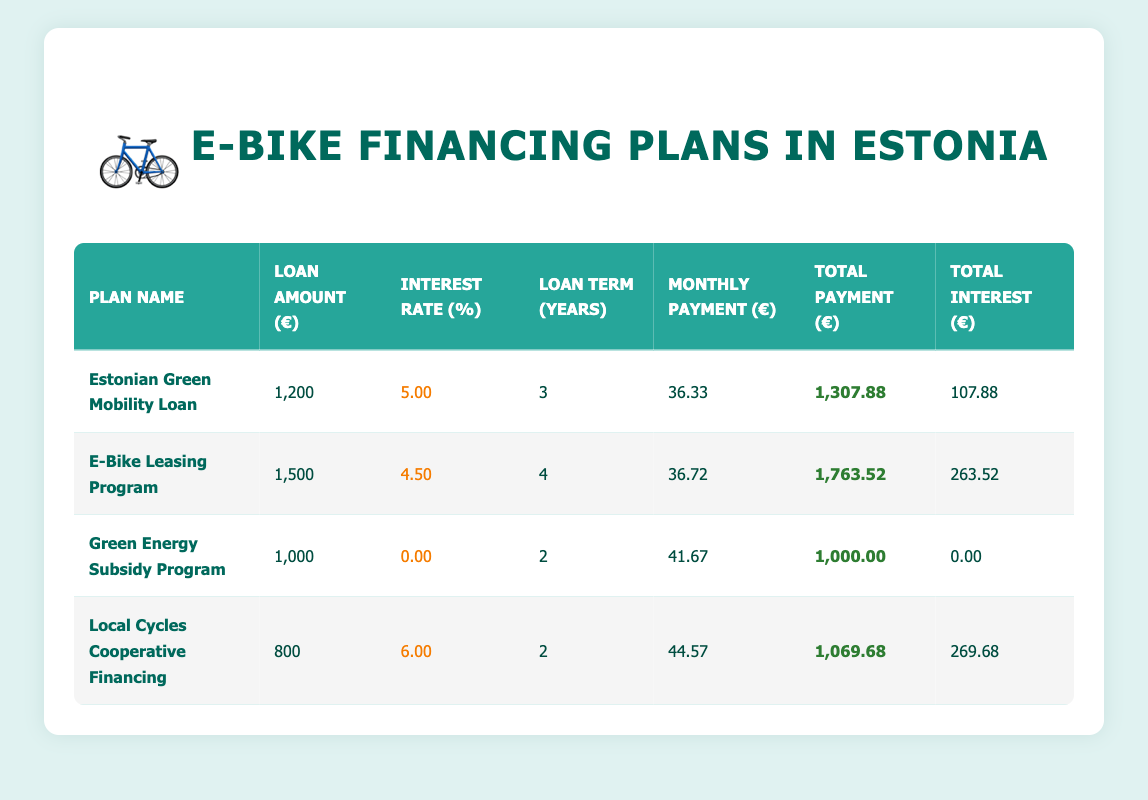What is the monthly payment for the "E-Bike Leasing Program"? To find the monthly payment for the "E-Bike Leasing Program", we look at the corresponding row in the table under the "Monthly Payment (€)" column. It shows 36.72.
Answer: 36.72 What is the total interest paid under the "Local Cycles Cooperative Financing"? In the row for "Local Cycles Cooperative Financing", the "Total Interest (€)" column displays the value 269.68.
Answer: 269.68 Which financing plan has the highest total payment? To determine this, we must compare the "Total Payment (€)" values across all financing plans. The "E-Bike Leasing Program" has the maximum total payment of 1,763.52.
Answer: E-Bike Leasing Program Is the interest rate for the "Green Energy Subsidy Program" 0 percent? Looking at the row for the "Green Energy Subsidy Program", the "Interest Rate (%)" column shows 0.00. Therefore, it confirms that the assertion is true.
Answer: Yes What is the difference in total payment between the "Estonian Green Mobility Loan" and the "Green Energy Subsidy Program"? The total payment for the "Estonian Green Mobility Loan" is 1,307.88, while for the "Green Energy Subsidy Program" it is 1,000.00. The difference is calculated as 1,307.88 - 1,000.00 = 307.88.
Answer: 307.88 How many financing plans have a loan term of 2 years? By checking the "Loan Term (Years)" column, we see that both the "Green Energy Subsidy Program" and "Local Cycles Cooperative Financing" have a loan term of 2 years. This gives us a total of 2 financing plans.
Answer: 2 What is the average interest rate of all financing plans? First, we add up the interest rates: 5.00 + 4.50 + 0.00 + 6.00 = 15.50. There are 4 plans, so we divide by 4: 15.50 / 4 = 3.875, which we round to 3.88.
Answer: 3.88 Which financing plan requires the largest loan amount? Checking the "Loan Amount (€)" column, the "E-Bike Leasing Program" has the largest loan amount of 1,500.
Answer: E-Bike Leasing Program Is the total payment for the "Green Energy Subsidy Program" equal to the loan amount? The "Green Energy Subsidy Program" shows a total payment of 1,000.00, which is the same as the loan amount listed. Hence, the statement is accurate.
Answer: Yes 